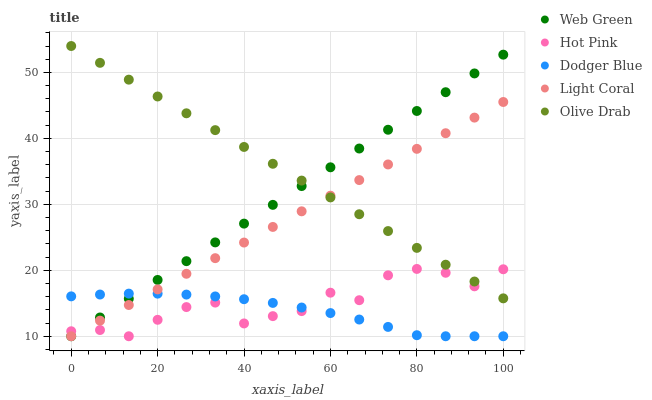Does Dodger Blue have the minimum area under the curve?
Answer yes or no. Yes. Does Olive Drab have the maximum area under the curve?
Answer yes or no. Yes. Does Hot Pink have the minimum area under the curve?
Answer yes or no. No. Does Hot Pink have the maximum area under the curve?
Answer yes or no. No. Is Web Green the smoothest?
Answer yes or no. Yes. Is Hot Pink the roughest?
Answer yes or no. Yes. Is Dodger Blue the smoothest?
Answer yes or no. No. Is Dodger Blue the roughest?
Answer yes or no. No. Does Light Coral have the lowest value?
Answer yes or no. Yes. Does Olive Drab have the lowest value?
Answer yes or no. No. Does Olive Drab have the highest value?
Answer yes or no. Yes. Does Hot Pink have the highest value?
Answer yes or no. No. Is Dodger Blue less than Olive Drab?
Answer yes or no. Yes. Is Olive Drab greater than Dodger Blue?
Answer yes or no. Yes. Does Hot Pink intersect Light Coral?
Answer yes or no. Yes. Is Hot Pink less than Light Coral?
Answer yes or no. No. Is Hot Pink greater than Light Coral?
Answer yes or no. No. Does Dodger Blue intersect Olive Drab?
Answer yes or no. No. 